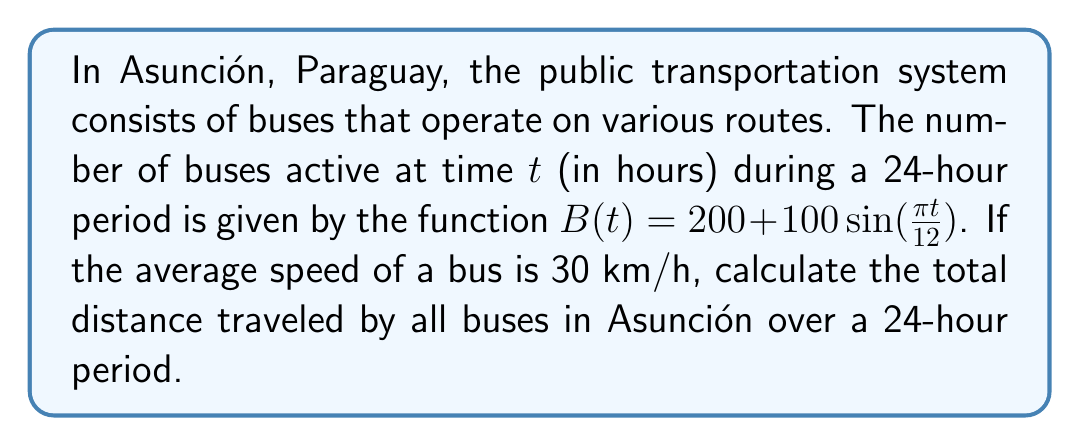What is the answer to this math problem? To solve this problem, we need to follow these steps:

1) The total distance traveled is the integral of the product of the number of buses and their speed over the 24-hour period.

2) Let's define our integral:
   $$\text{Total Distance} = \int_0^{24} 30 \cdot B(t) \, dt$$

3) Substitute the function $B(t)$:
   $$\text{Total Distance} = \int_0^{24} 30 \cdot (200 + 100\sin(\frac{\pi t}{12})) \, dt$$

4) Simplify:
   $$\text{Total Distance} = 30 \int_0^{24} (200 + 100\sin(\frac{\pi t}{12})) \, dt$$

5) Integrate:
   $$\text{Total Distance} = 30 \left[200t - \frac{1200}{\pi}\cos(\frac{\pi t}{12})\right]_0^{24}$$

6) Evaluate the integral:
   $$\text{Total Distance} = 30 \left[(200 \cdot 24 - \frac{1200}{\pi}\cos(2\pi)) - (0 - \frac{1200}{\pi}\cos(0))\right]$$

7) Simplify:
   $$\text{Total Distance} = 30 \left[4800 - \frac{1200}{\pi} + \frac{1200}{\pi}\right] = 30 \cdot 4800 = 144,000$$

Therefore, the total distance traveled by all buses in Asunción over a 24-hour period is 144,000 km.
Answer: 144,000 km 